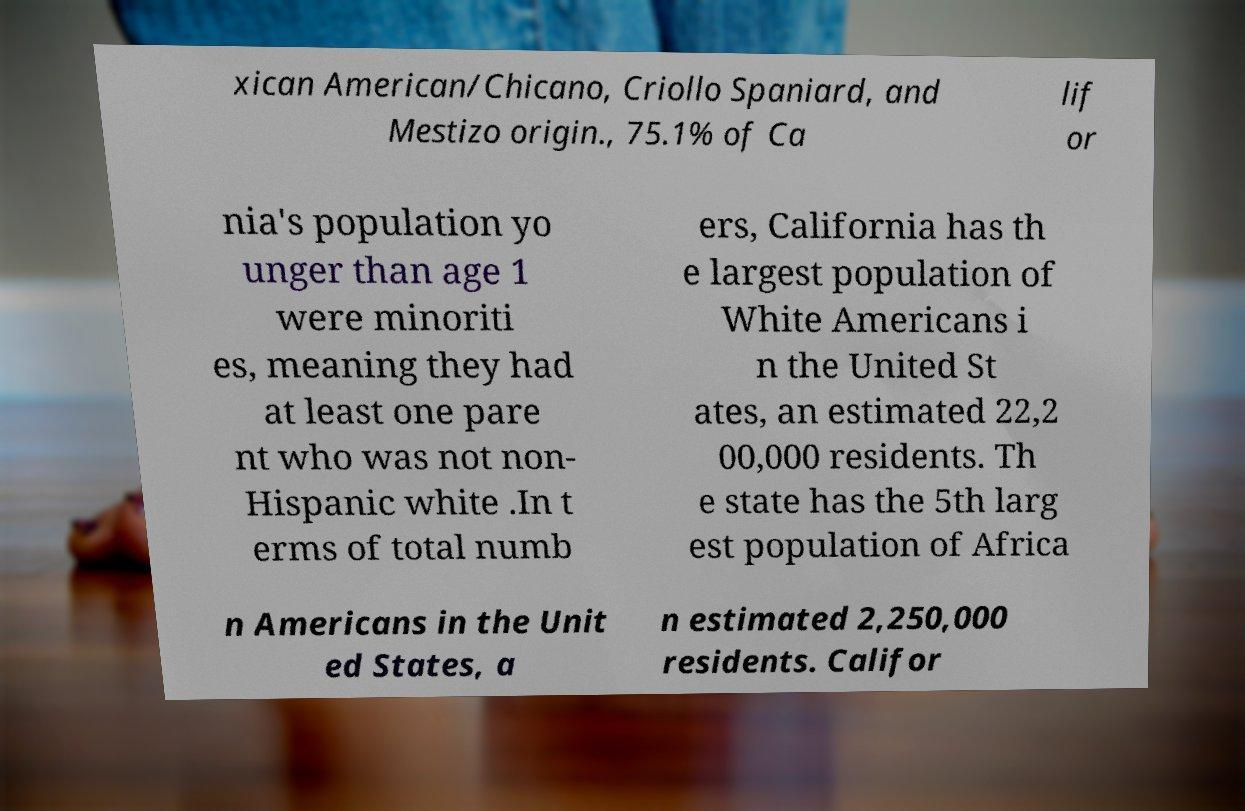I need the written content from this picture converted into text. Can you do that? xican American/Chicano, Criollo Spaniard, and Mestizo origin., 75.1% of Ca lif or nia's population yo unger than age 1 were minoriti es, meaning they had at least one pare nt who was not non- Hispanic white .In t erms of total numb ers, California has th e largest population of White Americans i n the United St ates, an estimated 22,2 00,000 residents. Th e state has the 5th larg est population of Africa n Americans in the Unit ed States, a n estimated 2,250,000 residents. Califor 